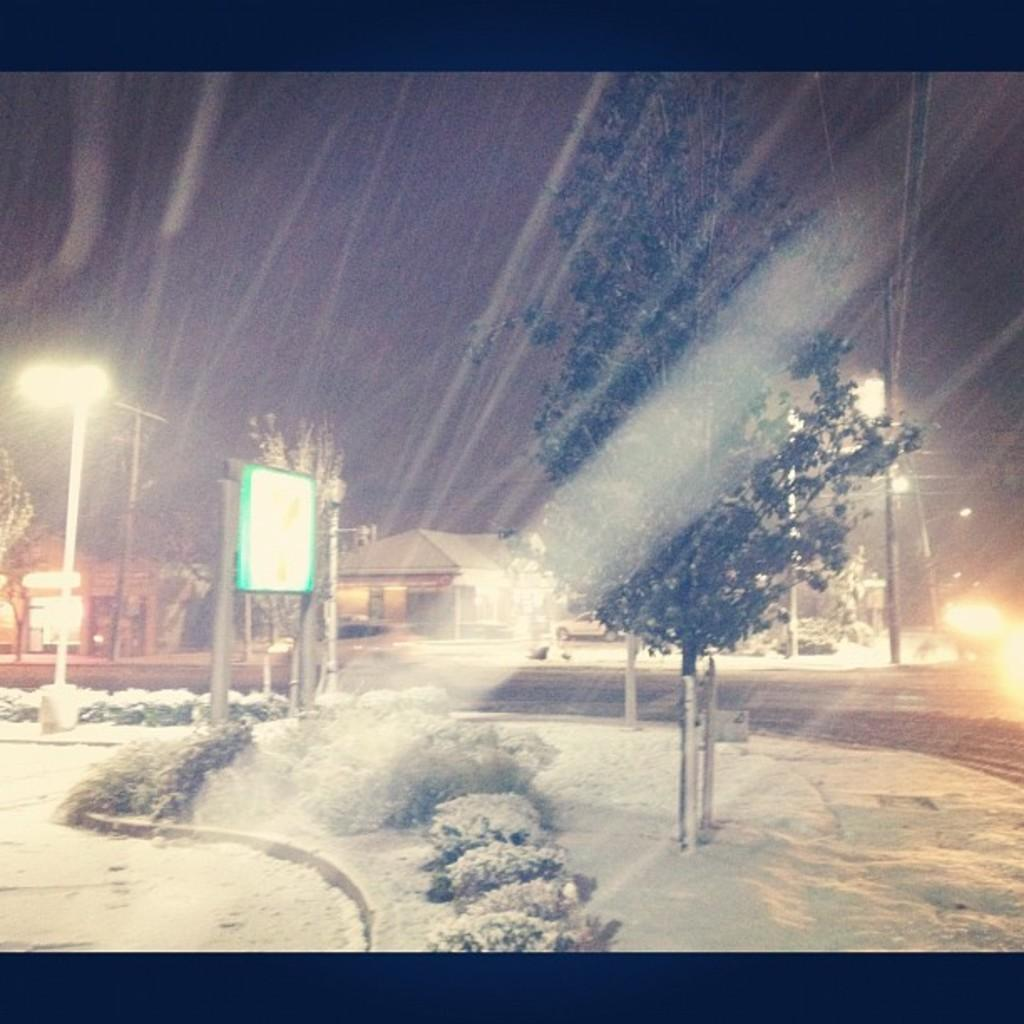What type of vegetation can be seen in the image? There are plants and trees in the image. What is the snowboard used for? The snowboard is used for winter sports or recreational activities. What structures can be seen in the background of the image? There are houses, poles, and a road in the background of the image. What is the color of the sky in the background of the image? The sky is dark in the background of the image. Can you tell me which berry is growing on the ground in the image? There is no berry growing on the ground in the image; it features plants, trees, a snowboard, and structures in the background. What rule is being enforced by the houses in the background of the image? There is no rule being enforced by the houses in the image; they are simply structures in the background. 